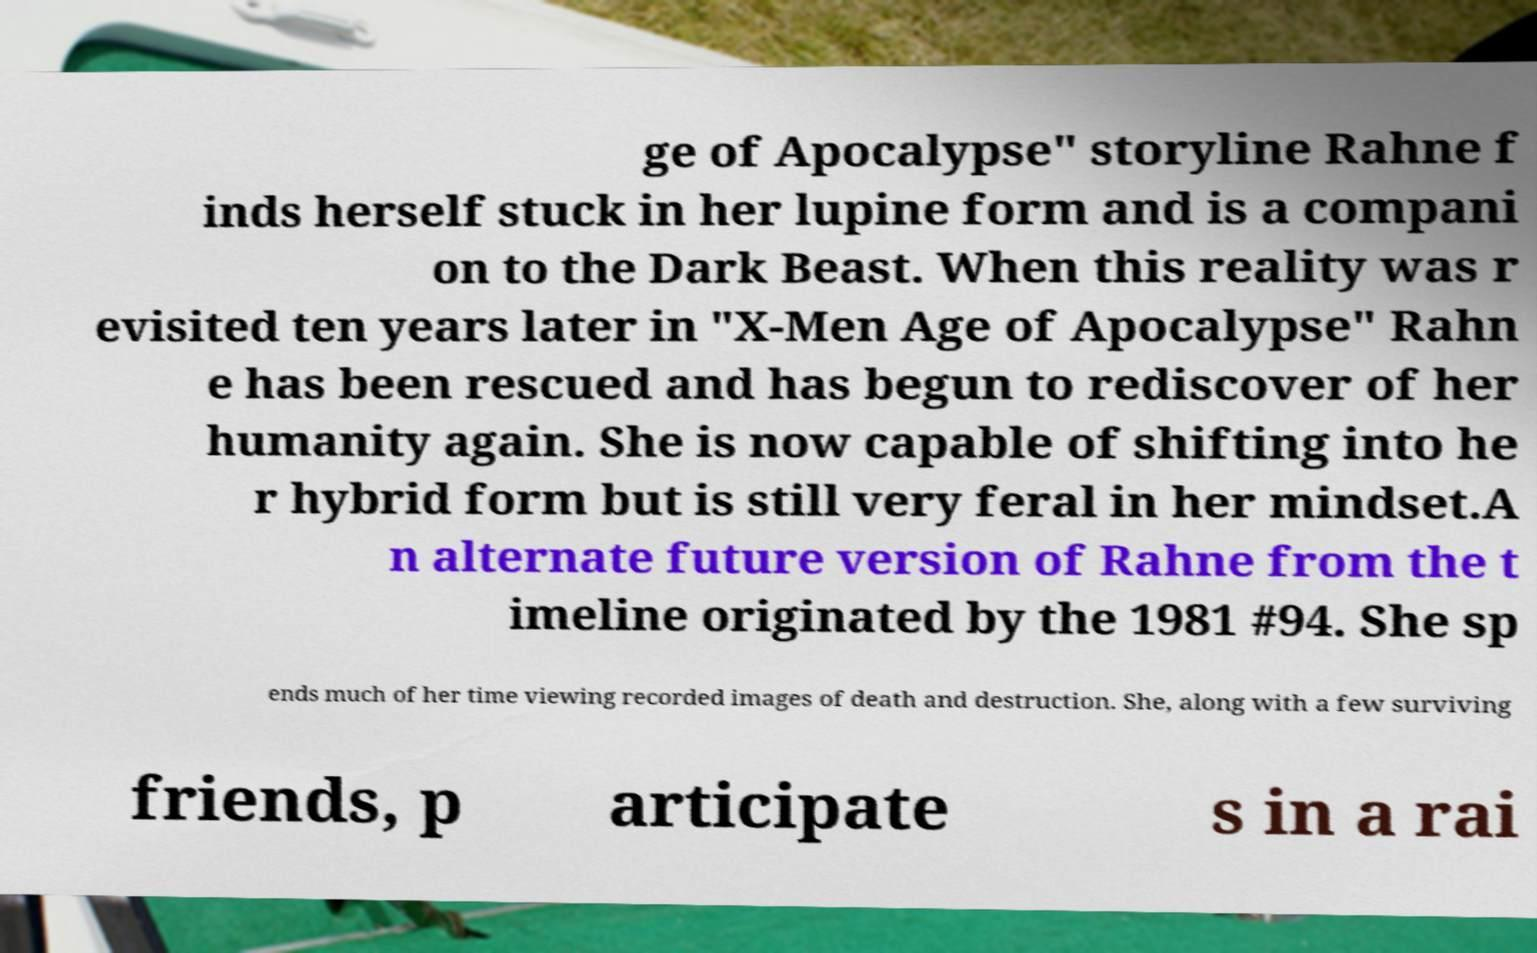For documentation purposes, I need the text within this image transcribed. Could you provide that? ge of Apocalypse" storyline Rahne f inds herself stuck in her lupine form and is a compani on to the Dark Beast. When this reality was r evisited ten years later in "X-Men Age of Apocalypse" Rahn e has been rescued and has begun to rediscover of her humanity again. She is now capable of shifting into he r hybrid form but is still very feral in her mindset.A n alternate future version of Rahne from the t imeline originated by the 1981 #94. She sp ends much of her time viewing recorded images of death and destruction. She, along with a few surviving friends, p articipate s in a rai 